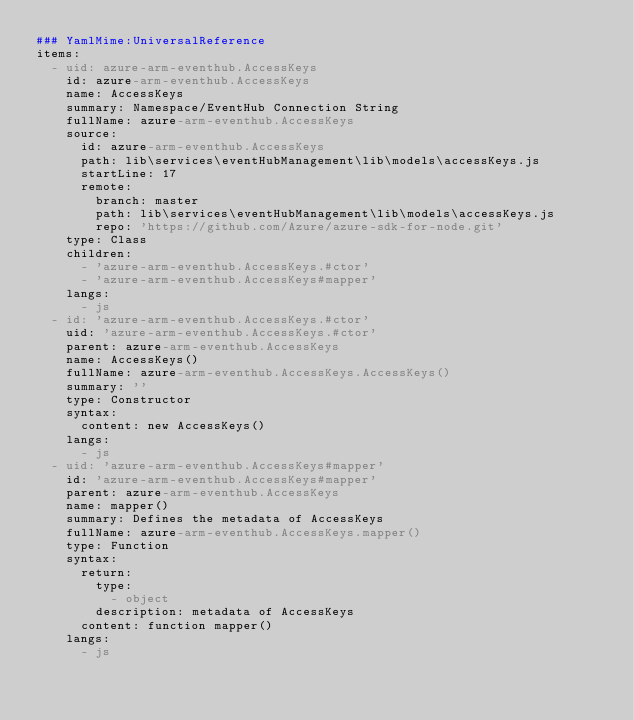<code> <loc_0><loc_0><loc_500><loc_500><_YAML_>### YamlMime:UniversalReference
items:
  - uid: azure-arm-eventhub.AccessKeys
    id: azure-arm-eventhub.AccessKeys
    name: AccessKeys
    summary: Namespace/EventHub Connection String
    fullName: azure-arm-eventhub.AccessKeys
    source:
      id: azure-arm-eventhub.AccessKeys
      path: lib\services\eventHubManagement\lib\models\accessKeys.js
      startLine: 17
      remote:
        branch: master
        path: lib\services\eventHubManagement\lib\models\accessKeys.js
        repo: 'https://github.com/Azure/azure-sdk-for-node.git'
    type: Class
    children:
      - 'azure-arm-eventhub.AccessKeys.#ctor'
      - 'azure-arm-eventhub.AccessKeys#mapper'
    langs:
      - js
  - id: 'azure-arm-eventhub.AccessKeys.#ctor'
    uid: 'azure-arm-eventhub.AccessKeys.#ctor'
    parent: azure-arm-eventhub.AccessKeys
    name: AccessKeys()
    fullName: azure-arm-eventhub.AccessKeys.AccessKeys()
    summary: ''
    type: Constructor
    syntax:
      content: new AccessKeys()
    langs:
      - js
  - uid: 'azure-arm-eventhub.AccessKeys#mapper'
    id: 'azure-arm-eventhub.AccessKeys#mapper'
    parent: azure-arm-eventhub.AccessKeys
    name: mapper()
    summary: Defines the metadata of AccessKeys
    fullName: azure-arm-eventhub.AccessKeys.mapper()
    type: Function
    syntax:
      return:
        type:
          - object
        description: metadata of AccessKeys
      content: function mapper()
    langs:
      - js
</code> 